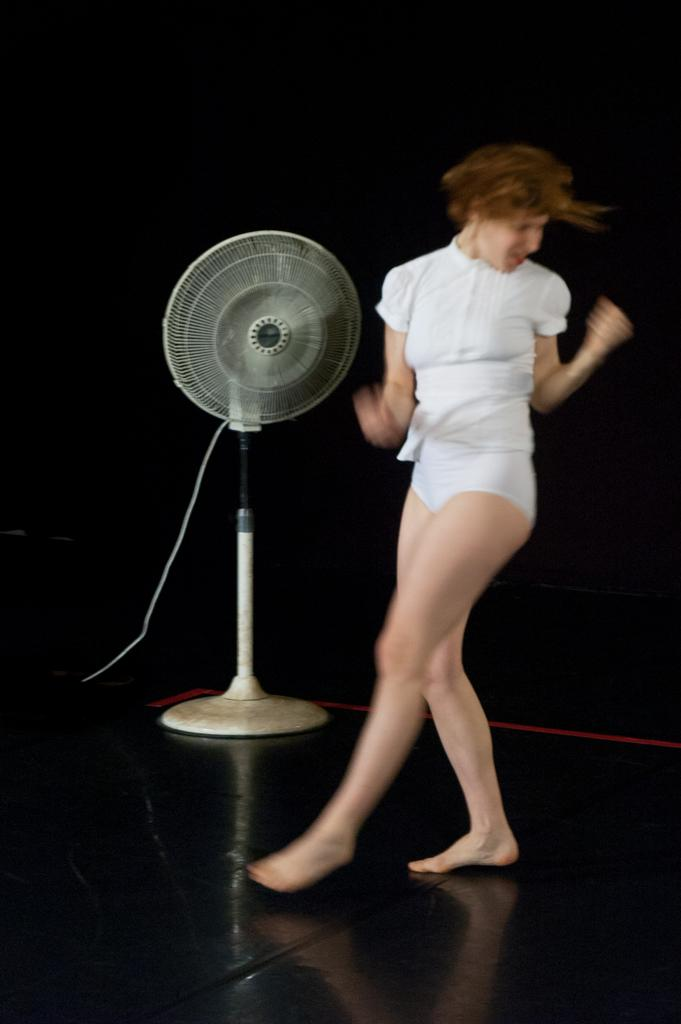Who is the main subject in the image? There is a woman in the image. What is the woman wearing? The woman is wearing a white dress. What is the woman doing in the image? The woman is dancing. What object is located beside the woman? There is a table fan beside the woman. What type of steel is used to make the table in the image? There is no table present in the image, so it is not possible to determine the type of steel used. What kind of meeting is taking place in the image? There is no meeting depicted in the image; the woman is dancing. 